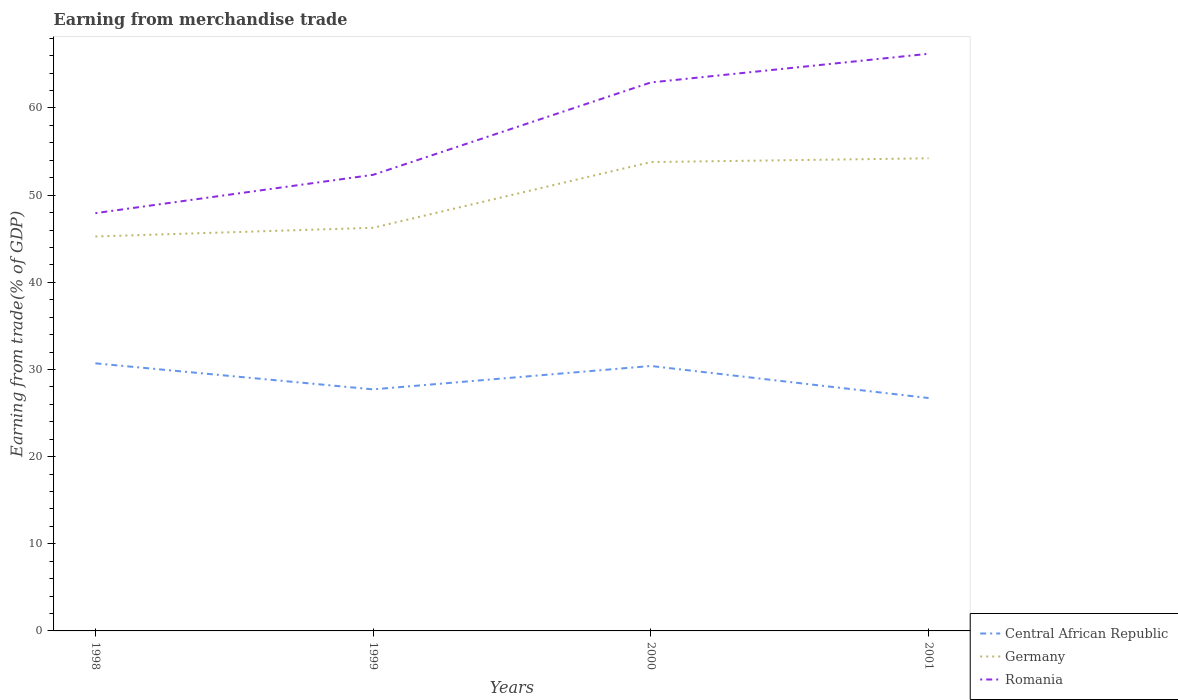How many different coloured lines are there?
Your response must be concise. 3. Does the line corresponding to Central African Republic intersect with the line corresponding to Germany?
Provide a short and direct response. No. Across all years, what is the maximum earnings from trade in Romania?
Give a very brief answer. 47.93. What is the total earnings from trade in Central African Republic in the graph?
Give a very brief answer. 0.3. What is the difference between the highest and the second highest earnings from trade in Germany?
Keep it short and to the point. 8.97. Is the earnings from trade in Romania strictly greater than the earnings from trade in Central African Republic over the years?
Make the answer very short. No. What is the difference between two consecutive major ticks on the Y-axis?
Your answer should be compact. 10. What is the title of the graph?
Provide a short and direct response. Earning from merchandise trade. What is the label or title of the X-axis?
Provide a short and direct response. Years. What is the label or title of the Y-axis?
Your answer should be compact. Earning from trade(% of GDP). What is the Earning from trade(% of GDP) of Central African Republic in 1998?
Your answer should be compact. 30.7. What is the Earning from trade(% of GDP) in Germany in 1998?
Offer a terse response. 45.26. What is the Earning from trade(% of GDP) of Romania in 1998?
Your answer should be very brief. 47.93. What is the Earning from trade(% of GDP) of Central African Republic in 1999?
Offer a very short reply. 27.71. What is the Earning from trade(% of GDP) of Germany in 1999?
Make the answer very short. 46.25. What is the Earning from trade(% of GDP) in Romania in 1999?
Your answer should be compact. 52.33. What is the Earning from trade(% of GDP) of Central African Republic in 2000?
Offer a terse response. 30.4. What is the Earning from trade(% of GDP) in Germany in 2000?
Offer a very short reply. 53.8. What is the Earning from trade(% of GDP) of Romania in 2000?
Provide a succinct answer. 62.93. What is the Earning from trade(% of GDP) of Central African Republic in 2001?
Make the answer very short. 26.72. What is the Earning from trade(% of GDP) in Germany in 2001?
Provide a short and direct response. 54.23. What is the Earning from trade(% of GDP) in Romania in 2001?
Give a very brief answer. 66.22. Across all years, what is the maximum Earning from trade(% of GDP) of Central African Republic?
Give a very brief answer. 30.7. Across all years, what is the maximum Earning from trade(% of GDP) in Germany?
Keep it short and to the point. 54.23. Across all years, what is the maximum Earning from trade(% of GDP) of Romania?
Your answer should be compact. 66.22. Across all years, what is the minimum Earning from trade(% of GDP) of Central African Republic?
Keep it short and to the point. 26.72. Across all years, what is the minimum Earning from trade(% of GDP) in Germany?
Keep it short and to the point. 45.26. Across all years, what is the minimum Earning from trade(% of GDP) in Romania?
Your response must be concise. 47.93. What is the total Earning from trade(% of GDP) of Central African Republic in the graph?
Offer a terse response. 115.54. What is the total Earning from trade(% of GDP) of Germany in the graph?
Provide a succinct answer. 199.53. What is the total Earning from trade(% of GDP) of Romania in the graph?
Your response must be concise. 229.41. What is the difference between the Earning from trade(% of GDP) of Central African Republic in 1998 and that in 1999?
Provide a short and direct response. 2.99. What is the difference between the Earning from trade(% of GDP) in Germany in 1998 and that in 1999?
Provide a succinct answer. -1. What is the difference between the Earning from trade(% of GDP) of Romania in 1998 and that in 1999?
Your response must be concise. -4.4. What is the difference between the Earning from trade(% of GDP) of Central African Republic in 1998 and that in 2000?
Keep it short and to the point. 0.3. What is the difference between the Earning from trade(% of GDP) in Germany in 1998 and that in 2000?
Provide a succinct answer. -8.54. What is the difference between the Earning from trade(% of GDP) of Romania in 1998 and that in 2000?
Your answer should be compact. -14.99. What is the difference between the Earning from trade(% of GDP) of Central African Republic in 1998 and that in 2001?
Offer a terse response. 3.98. What is the difference between the Earning from trade(% of GDP) of Germany in 1998 and that in 2001?
Offer a terse response. -8.97. What is the difference between the Earning from trade(% of GDP) in Romania in 1998 and that in 2001?
Provide a succinct answer. -18.28. What is the difference between the Earning from trade(% of GDP) of Central African Republic in 1999 and that in 2000?
Ensure brevity in your answer.  -2.68. What is the difference between the Earning from trade(% of GDP) in Germany in 1999 and that in 2000?
Your response must be concise. -7.54. What is the difference between the Earning from trade(% of GDP) in Romania in 1999 and that in 2000?
Keep it short and to the point. -10.6. What is the difference between the Earning from trade(% of GDP) in Central African Republic in 1999 and that in 2001?
Your response must be concise. 0.99. What is the difference between the Earning from trade(% of GDP) of Germany in 1999 and that in 2001?
Your answer should be very brief. -7.97. What is the difference between the Earning from trade(% of GDP) of Romania in 1999 and that in 2001?
Your answer should be very brief. -13.89. What is the difference between the Earning from trade(% of GDP) in Central African Republic in 2000 and that in 2001?
Make the answer very short. 3.68. What is the difference between the Earning from trade(% of GDP) in Germany in 2000 and that in 2001?
Provide a succinct answer. -0.43. What is the difference between the Earning from trade(% of GDP) of Romania in 2000 and that in 2001?
Offer a terse response. -3.29. What is the difference between the Earning from trade(% of GDP) of Central African Republic in 1998 and the Earning from trade(% of GDP) of Germany in 1999?
Your answer should be compact. -15.55. What is the difference between the Earning from trade(% of GDP) of Central African Republic in 1998 and the Earning from trade(% of GDP) of Romania in 1999?
Provide a short and direct response. -21.63. What is the difference between the Earning from trade(% of GDP) in Germany in 1998 and the Earning from trade(% of GDP) in Romania in 1999?
Make the answer very short. -7.07. What is the difference between the Earning from trade(% of GDP) in Central African Republic in 1998 and the Earning from trade(% of GDP) in Germany in 2000?
Offer a very short reply. -23.09. What is the difference between the Earning from trade(% of GDP) of Central African Republic in 1998 and the Earning from trade(% of GDP) of Romania in 2000?
Give a very brief answer. -32.23. What is the difference between the Earning from trade(% of GDP) of Germany in 1998 and the Earning from trade(% of GDP) of Romania in 2000?
Offer a terse response. -17.67. What is the difference between the Earning from trade(% of GDP) in Central African Republic in 1998 and the Earning from trade(% of GDP) in Germany in 2001?
Give a very brief answer. -23.52. What is the difference between the Earning from trade(% of GDP) of Central African Republic in 1998 and the Earning from trade(% of GDP) of Romania in 2001?
Provide a short and direct response. -35.52. What is the difference between the Earning from trade(% of GDP) in Germany in 1998 and the Earning from trade(% of GDP) in Romania in 2001?
Ensure brevity in your answer.  -20.96. What is the difference between the Earning from trade(% of GDP) of Central African Republic in 1999 and the Earning from trade(% of GDP) of Germany in 2000?
Your answer should be very brief. -26.08. What is the difference between the Earning from trade(% of GDP) in Central African Republic in 1999 and the Earning from trade(% of GDP) in Romania in 2000?
Keep it short and to the point. -35.21. What is the difference between the Earning from trade(% of GDP) in Germany in 1999 and the Earning from trade(% of GDP) in Romania in 2000?
Give a very brief answer. -16.67. What is the difference between the Earning from trade(% of GDP) in Central African Republic in 1999 and the Earning from trade(% of GDP) in Germany in 2001?
Ensure brevity in your answer.  -26.51. What is the difference between the Earning from trade(% of GDP) of Central African Republic in 1999 and the Earning from trade(% of GDP) of Romania in 2001?
Your answer should be very brief. -38.5. What is the difference between the Earning from trade(% of GDP) of Germany in 1999 and the Earning from trade(% of GDP) of Romania in 2001?
Offer a very short reply. -19.96. What is the difference between the Earning from trade(% of GDP) in Central African Republic in 2000 and the Earning from trade(% of GDP) in Germany in 2001?
Make the answer very short. -23.83. What is the difference between the Earning from trade(% of GDP) in Central African Republic in 2000 and the Earning from trade(% of GDP) in Romania in 2001?
Offer a very short reply. -35.82. What is the difference between the Earning from trade(% of GDP) of Germany in 2000 and the Earning from trade(% of GDP) of Romania in 2001?
Keep it short and to the point. -12.42. What is the average Earning from trade(% of GDP) of Central African Republic per year?
Offer a terse response. 28.88. What is the average Earning from trade(% of GDP) in Germany per year?
Provide a short and direct response. 49.88. What is the average Earning from trade(% of GDP) in Romania per year?
Your answer should be compact. 57.35. In the year 1998, what is the difference between the Earning from trade(% of GDP) of Central African Republic and Earning from trade(% of GDP) of Germany?
Your response must be concise. -14.55. In the year 1998, what is the difference between the Earning from trade(% of GDP) of Central African Republic and Earning from trade(% of GDP) of Romania?
Give a very brief answer. -17.23. In the year 1998, what is the difference between the Earning from trade(% of GDP) of Germany and Earning from trade(% of GDP) of Romania?
Provide a succinct answer. -2.68. In the year 1999, what is the difference between the Earning from trade(% of GDP) of Central African Republic and Earning from trade(% of GDP) of Germany?
Ensure brevity in your answer.  -18.54. In the year 1999, what is the difference between the Earning from trade(% of GDP) of Central African Republic and Earning from trade(% of GDP) of Romania?
Make the answer very short. -24.62. In the year 1999, what is the difference between the Earning from trade(% of GDP) in Germany and Earning from trade(% of GDP) in Romania?
Offer a very short reply. -6.08. In the year 2000, what is the difference between the Earning from trade(% of GDP) of Central African Republic and Earning from trade(% of GDP) of Germany?
Give a very brief answer. -23.4. In the year 2000, what is the difference between the Earning from trade(% of GDP) of Central African Republic and Earning from trade(% of GDP) of Romania?
Make the answer very short. -32.53. In the year 2000, what is the difference between the Earning from trade(% of GDP) of Germany and Earning from trade(% of GDP) of Romania?
Provide a short and direct response. -9.13. In the year 2001, what is the difference between the Earning from trade(% of GDP) in Central African Republic and Earning from trade(% of GDP) in Germany?
Offer a terse response. -27.5. In the year 2001, what is the difference between the Earning from trade(% of GDP) in Central African Republic and Earning from trade(% of GDP) in Romania?
Your response must be concise. -39.5. In the year 2001, what is the difference between the Earning from trade(% of GDP) of Germany and Earning from trade(% of GDP) of Romania?
Provide a short and direct response. -11.99. What is the ratio of the Earning from trade(% of GDP) of Central African Republic in 1998 to that in 1999?
Ensure brevity in your answer.  1.11. What is the ratio of the Earning from trade(% of GDP) of Germany in 1998 to that in 1999?
Offer a very short reply. 0.98. What is the ratio of the Earning from trade(% of GDP) of Romania in 1998 to that in 1999?
Ensure brevity in your answer.  0.92. What is the ratio of the Earning from trade(% of GDP) in Central African Republic in 1998 to that in 2000?
Provide a succinct answer. 1.01. What is the ratio of the Earning from trade(% of GDP) in Germany in 1998 to that in 2000?
Offer a terse response. 0.84. What is the ratio of the Earning from trade(% of GDP) in Romania in 1998 to that in 2000?
Provide a short and direct response. 0.76. What is the ratio of the Earning from trade(% of GDP) of Central African Republic in 1998 to that in 2001?
Provide a short and direct response. 1.15. What is the ratio of the Earning from trade(% of GDP) in Germany in 1998 to that in 2001?
Provide a succinct answer. 0.83. What is the ratio of the Earning from trade(% of GDP) in Romania in 1998 to that in 2001?
Offer a terse response. 0.72. What is the ratio of the Earning from trade(% of GDP) in Central African Republic in 1999 to that in 2000?
Ensure brevity in your answer.  0.91. What is the ratio of the Earning from trade(% of GDP) of Germany in 1999 to that in 2000?
Offer a very short reply. 0.86. What is the ratio of the Earning from trade(% of GDP) of Romania in 1999 to that in 2000?
Your answer should be compact. 0.83. What is the ratio of the Earning from trade(% of GDP) in Central African Republic in 1999 to that in 2001?
Provide a short and direct response. 1.04. What is the ratio of the Earning from trade(% of GDP) in Germany in 1999 to that in 2001?
Make the answer very short. 0.85. What is the ratio of the Earning from trade(% of GDP) of Romania in 1999 to that in 2001?
Make the answer very short. 0.79. What is the ratio of the Earning from trade(% of GDP) of Central African Republic in 2000 to that in 2001?
Give a very brief answer. 1.14. What is the ratio of the Earning from trade(% of GDP) of Romania in 2000 to that in 2001?
Offer a very short reply. 0.95. What is the difference between the highest and the second highest Earning from trade(% of GDP) in Central African Republic?
Ensure brevity in your answer.  0.3. What is the difference between the highest and the second highest Earning from trade(% of GDP) of Germany?
Provide a succinct answer. 0.43. What is the difference between the highest and the second highest Earning from trade(% of GDP) of Romania?
Ensure brevity in your answer.  3.29. What is the difference between the highest and the lowest Earning from trade(% of GDP) in Central African Republic?
Give a very brief answer. 3.98. What is the difference between the highest and the lowest Earning from trade(% of GDP) of Germany?
Offer a very short reply. 8.97. What is the difference between the highest and the lowest Earning from trade(% of GDP) in Romania?
Give a very brief answer. 18.28. 